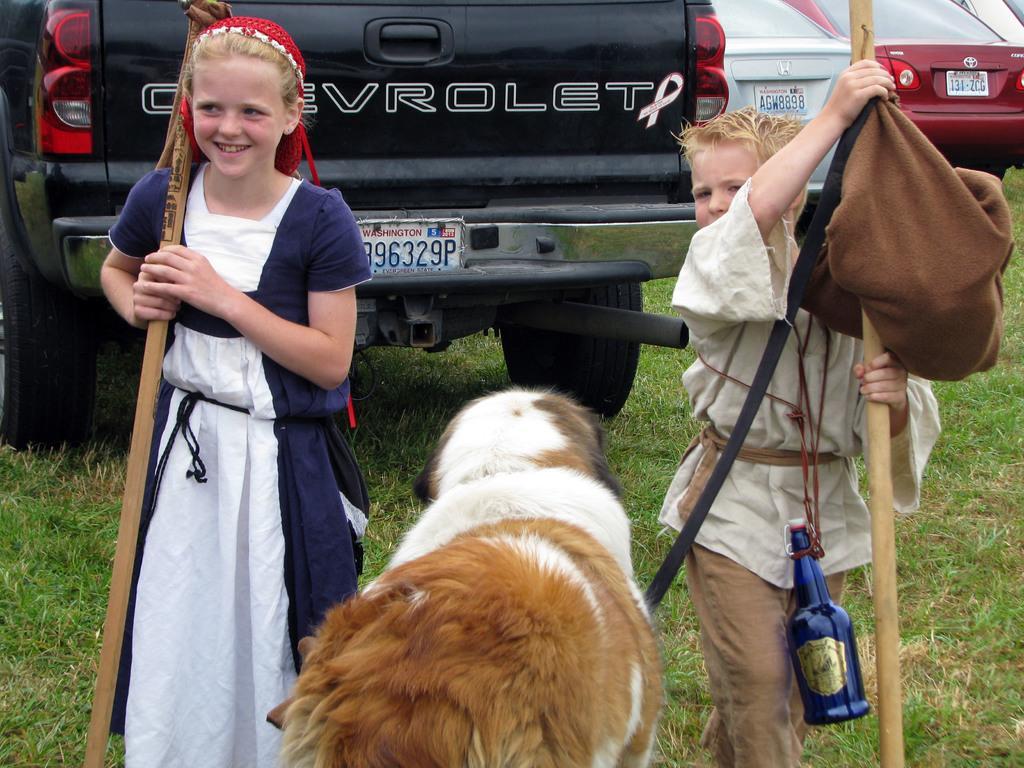In one or two sentences, can you explain what this image depicts? This is the picture of a place where we have two kids holding sticks, dog on the floor and behind there are some cars on the grass floor. 